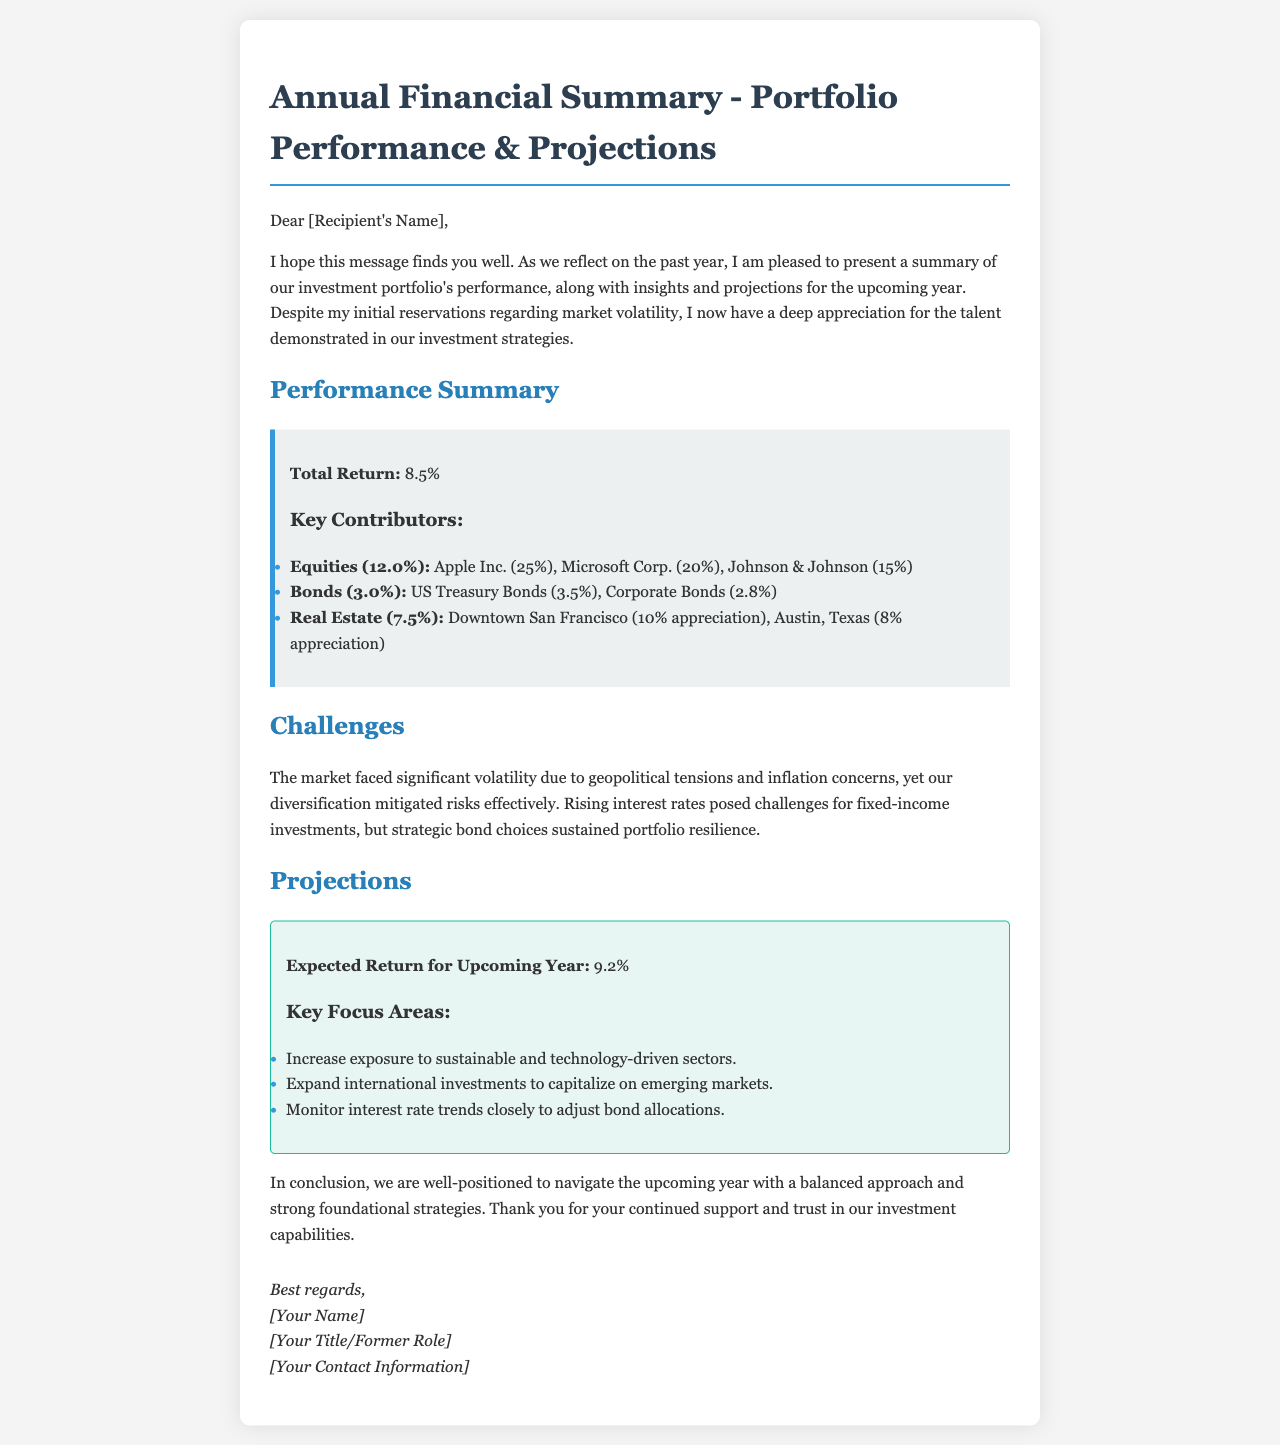What was the total return for the investment portfolio last year? The total return is explicitly stated in the performance summary section of the document.
Answer: 8.5% Which company had the highest contribution in equities? The performance summary lists specific contributions of various companies, highlighting that Apple Inc. had the highest contribution of 25%.
Answer: Apple Inc What was the expected return for the upcoming year? The projections section clearly indicates the expected return for the upcoming year.
Answer: 9.2% What key focus area involves expanding investments internationally? The projections section mentions expanding international investments as a key focus area for future growth.
Answer: Expand international investments How did market volatility affect fixed-income investments? The document explains that rising interest rates posed challenges, but strategic bond choices sustained portfolio resilience, indicating a thoughtful response to market conditions.
Answer: Strategic bond choices What type of investments contributed 3.0% last year? The performance summary includes Bonds with a contribution of 3.0%.
Answer: Bonds Which city showed a 10% appreciation in real estate? The performance box details specific locations, clearly stating that Downtown San Francisco had a 10% appreciation.
Answer: Downtown San Francisco What were the primary contributors to the portfolio's total return? The performance summary outlines the contributions from equities, bonds, and real estate, necessitating a summary of these categories.
Answer: Equities, Bonds, Real Estate What challenges did the market face in the previous year? The challenges section notes significant volatility due to geopolitical tensions and inflation concerns.
Answer: Geopolitical tensions and inflation concerns 